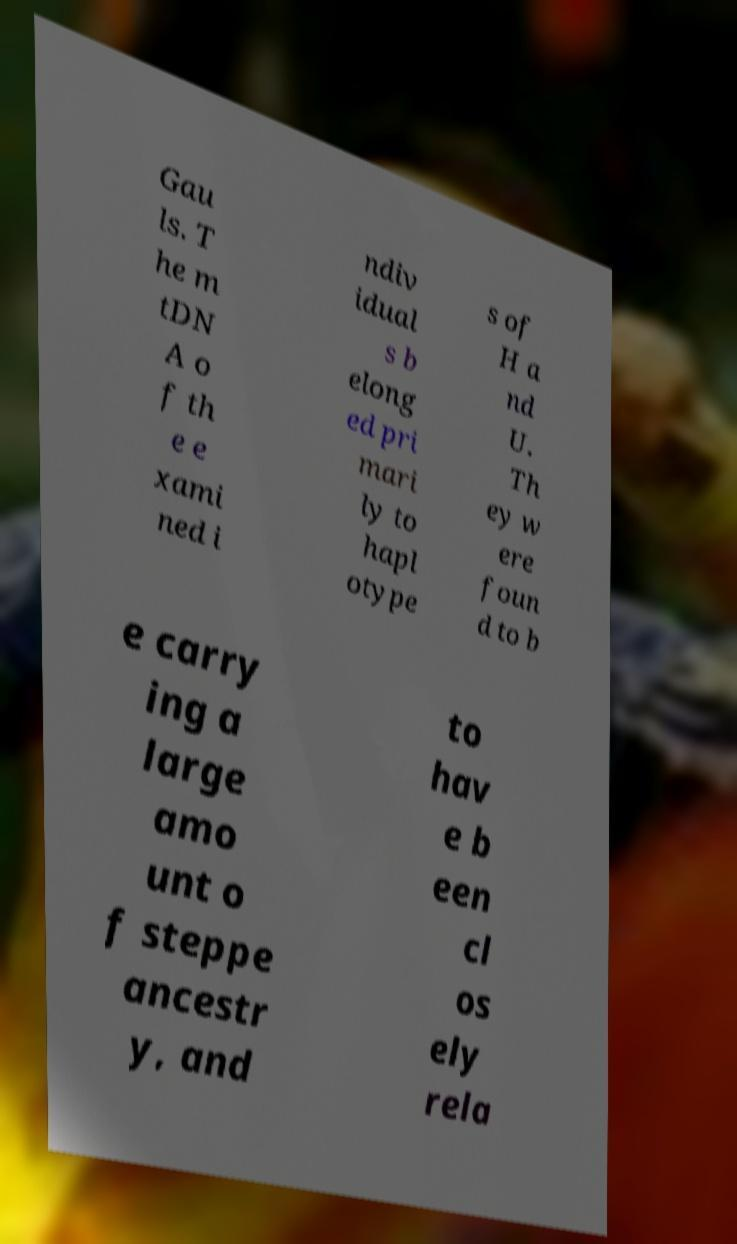There's text embedded in this image that I need extracted. Can you transcribe it verbatim? Gau ls. T he m tDN A o f th e e xami ned i ndiv idual s b elong ed pri mari ly to hapl otype s of H a nd U. Th ey w ere foun d to b e carry ing a large amo unt o f steppe ancestr y, and to hav e b een cl os ely rela 